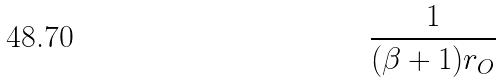<formula> <loc_0><loc_0><loc_500><loc_500>\frac { 1 } { ( \beta + 1 ) r _ { O } }</formula> 